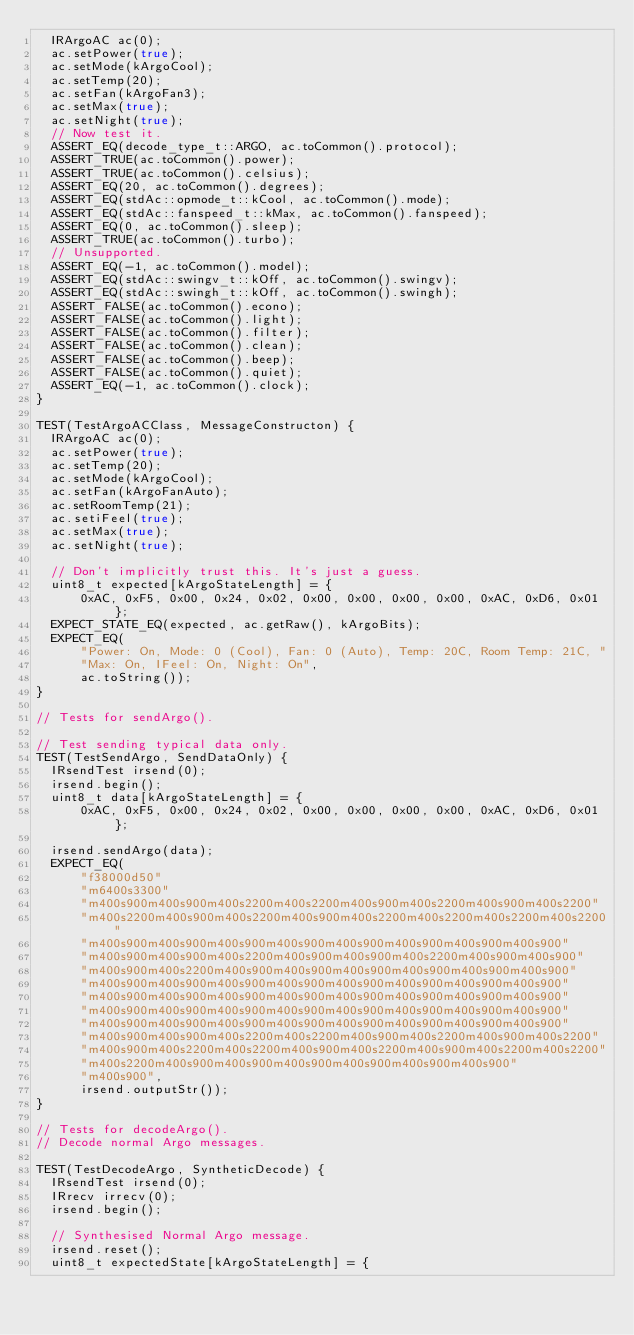<code> <loc_0><loc_0><loc_500><loc_500><_C++_>  IRArgoAC ac(0);
  ac.setPower(true);
  ac.setMode(kArgoCool);
  ac.setTemp(20);
  ac.setFan(kArgoFan3);
  ac.setMax(true);
  ac.setNight(true);
  // Now test it.
  ASSERT_EQ(decode_type_t::ARGO, ac.toCommon().protocol);
  ASSERT_TRUE(ac.toCommon().power);
  ASSERT_TRUE(ac.toCommon().celsius);
  ASSERT_EQ(20, ac.toCommon().degrees);
  ASSERT_EQ(stdAc::opmode_t::kCool, ac.toCommon().mode);
  ASSERT_EQ(stdAc::fanspeed_t::kMax, ac.toCommon().fanspeed);
  ASSERT_EQ(0, ac.toCommon().sleep);
  ASSERT_TRUE(ac.toCommon().turbo);
  // Unsupported.
  ASSERT_EQ(-1, ac.toCommon().model);
  ASSERT_EQ(stdAc::swingv_t::kOff, ac.toCommon().swingv);
  ASSERT_EQ(stdAc::swingh_t::kOff, ac.toCommon().swingh);
  ASSERT_FALSE(ac.toCommon().econo);
  ASSERT_FALSE(ac.toCommon().light);
  ASSERT_FALSE(ac.toCommon().filter);
  ASSERT_FALSE(ac.toCommon().clean);
  ASSERT_FALSE(ac.toCommon().beep);
  ASSERT_FALSE(ac.toCommon().quiet);
  ASSERT_EQ(-1, ac.toCommon().clock);
}

TEST(TestArgoACClass, MessageConstructon) {
  IRArgoAC ac(0);
  ac.setPower(true);
  ac.setTemp(20);
  ac.setMode(kArgoCool);
  ac.setFan(kArgoFanAuto);
  ac.setRoomTemp(21);
  ac.setiFeel(true);
  ac.setMax(true);
  ac.setNight(true);

  // Don't implicitly trust this. It's just a guess.
  uint8_t expected[kArgoStateLength] = {
      0xAC, 0xF5, 0x00, 0x24, 0x02, 0x00, 0x00, 0x00, 0x00, 0xAC, 0xD6, 0x01};
  EXPECT_STATE_EQ(expected, ac.getRaw(), kArgoBits);
  EXPECT_EQ(
      "Power: On, Mode: 0 (Cool), Fan: 0 (Auto), Temp: 20C, Room Temp: 21C, "
      "Max: On, IFeel: On, Night: On",
      ac.toString());
}

// Tests for sendArgo().

// Test sending typical data only.
TEST(TestSendArgo, SendDataOnly) {
  IRsendTest irsend(0);
  irsend.begin();
  uint8_t data[kArgoStateLength] = {
      0xAC, 0xF5, 0x00, 0x24, 0x02, 0x00, 0x00, 0x00, 0x00, 0xAC, 0xD6, 0x01};

  irsend.sendArgo(data);
  EXPECT_EQ(
      "f38000d50"
      "m6400s3300"
      "m400s900m400s900m400s2200m400s2200m400s900m400s2200m400s900m400s2200"
      "m400s2200m400s900m400s2200m400s900m400s2200m400s2200m400s2200m400s2200"
      "m400s900m400s900m400s900m400s900m400s900m400s900m400s900m400s900"
      "m400s900m400s900m400s2200m400s900m400s900m400s2200m400s900m400s900"
      "m400s900m400s2200m400s900m400s900m400s900m400s900m400s900m400s900"
      "m400s900m400s900m400s900m400s900m400s900m400s900m400s900m400s900"
      "m400s900m400s900m400s900m400s900m400s900m400s900m400s900m400s900"
      "m400s900m400s900m400s900m400s900m400s900m400s900m400s900m400s900"
      "m400s900m400s900m400s900m400s900m400s900m400s900m400s900m400s900"
      "m400s900m400s900m400s2200m400s2200m400s900m400s2200m400s900m400s2200"
      "m400s900m400s2200m400s2200m400s900m400s2200m400s900m400s2200m400s2200"
      "m400s2200m400s900m400s900m400s900m400s900m400s900m400s900"
      "m400s900",
      irsend.outputStr());
}

// Tests for decodeArgo().
// Decode normal Argo messages.

TEST(TestDecodeArgo, SyntheticDecode) {
  IRsendTest irsend(0);
  IRrecv irrecv(0);
  irsend.begin();

  // Synthesised Normal Argo message.
  irsend.reset();
  uint8_t expectedState[kArgoStateLength] = {</code> 